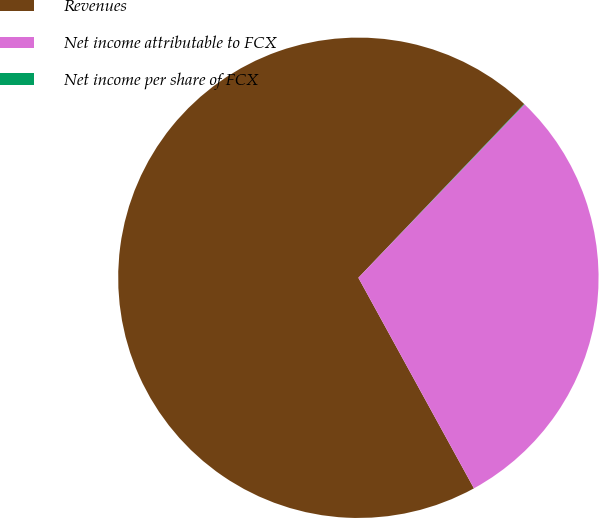<chart> <loc_0><loc_0><loc_500><loc_500><pie_chart><fcel>Revenues<fcel>Net income attributable to FCX<fcel>Net income per share of FCX<nl><fcel>70.11%<fcel>29.85%<fcel>0.03%<nl></chart> 